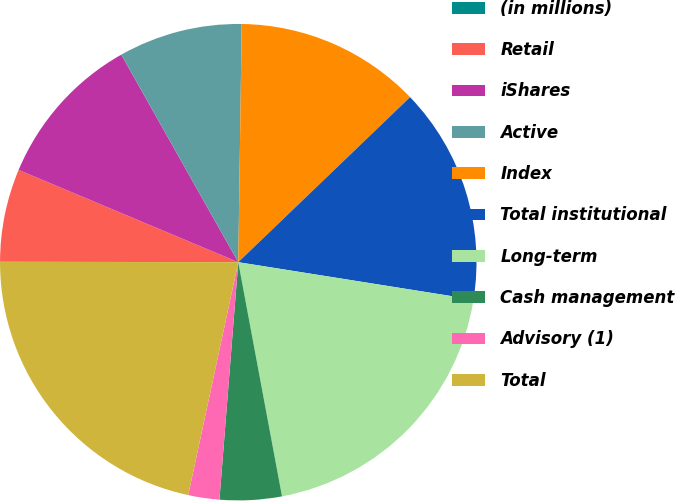Convert chart to OTSL. <chart><loc_0><loc_0><loc_500><loc_500><pie_chart><fcel>(in millions)<fcel>Retail<fcel>iShares<fcel>Active<fcel>Index<fcel>Total institutional<fcel>Long-term<fcel>Cash management<fcel>Advisory (1)<fcel>Total<nl><fcel>0.01%<fcel>6.3%<fcel>10.5%<fcel>8.4%<fcel>12.59%<fcel>14.69%<fcel>19.55%<fcel>4.2%<fcel>2.11%<fcel>21.65%<nl></chart> 